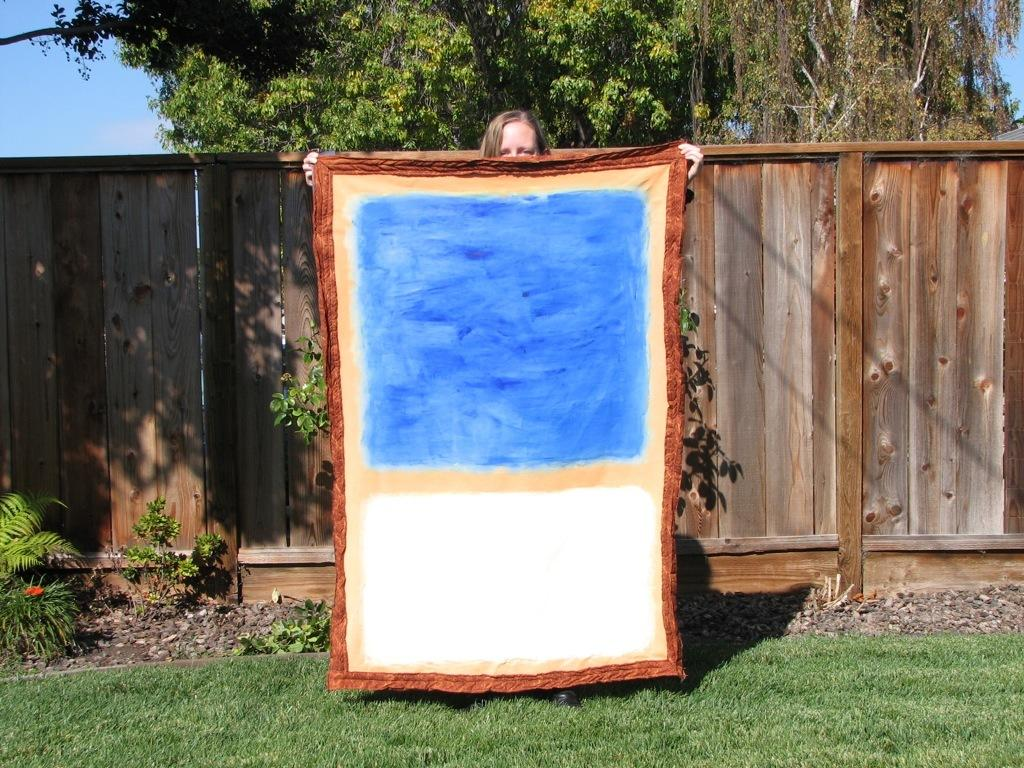What is the person in the image holding? The person is holding a cloth in the image. What type of vegetation can be seen in the image? There are plants and trees in the image. What is visible in the background of the image? The sky is visible in the image. What type of material is the wall made of in the image? The wall in the image is made of wood. What type of popcorn is being prepared in the image? There is no popcorn present in the image. What tool is the person using to hammer the wooden wall in the image? There is: There is no hammer or activity of hammering visible in the image. 